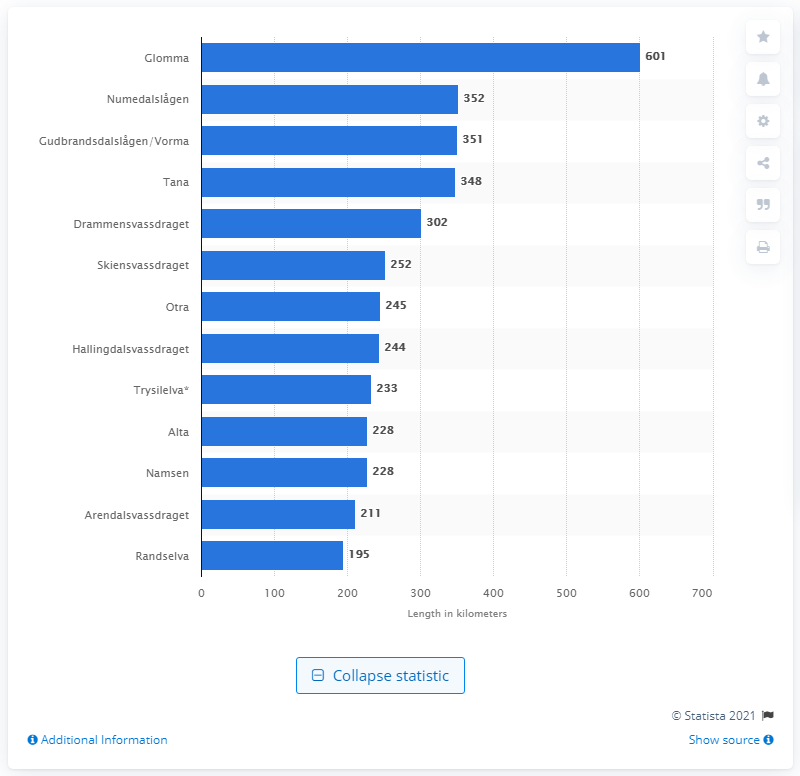Give some essential details in this illustration. Glomma is the longest river in Norway. 